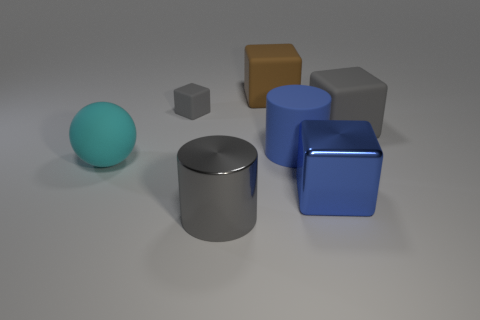What number of blocks are either cyan matte things or large blue objects?
Your answer should be compact. 1. There is a blue cylinder behind the metallic thing that is on the left side of the brown object; what number of large cylinders are on the left side of it?
Make the answer very short. 1. There is a big object that is the same color as the big matte cylinder; what is its material?
Give a very brief answer. Metal. Is the number of gray rubber things greater than the number of large cyan metal blocks?
Make the answer very short. Yes. Is the size of the cyan sphere the same as the blue shiny object?
Ensure brevity in your answer.  Yes. What number of things are either big gray matte blocks or metallic spheres?
Your response must be concise. 1. What is the shape of the large brown rubber thing behind the gray rubber cube that is on the left side of the big metallic thing that is right of the large shiny cylinder?
Keep it short and to the point. Cube. Do the big thing behind the large gray rubber object and the gray thing that is in front of the big gray matte cube have the same material?
Provide a succinct answer. No. What material is the other brown object that is the same shape as the small matte object?
Offer a terse response. Rubber. Is there any other thing that has the same size as the shiny cylinder?
Give a very brief answer. Yes. 